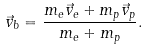Convert formula to latex. <formula><loc_0><loc_0><loc_500><loc_500>\vec { v } _ { b } = \frac { m _ { e } \vec { v } _ { e } + m _ { p } \vec { v } _ { p } } { m _ { e } + m _ { p } } .</formula> 